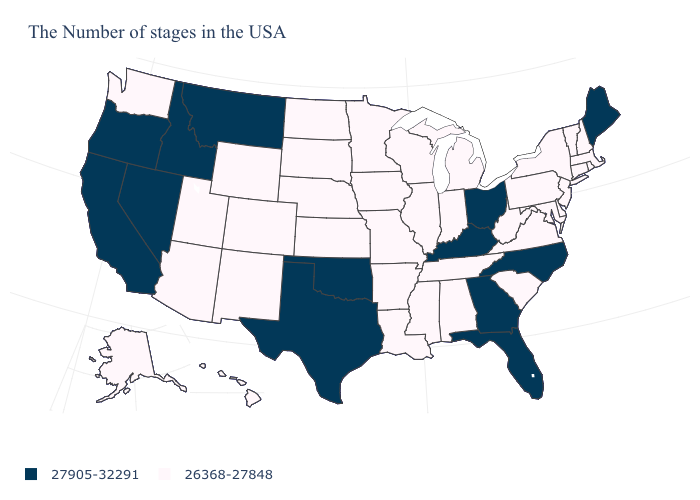What is the value of Alaska?
Quick response, please. 26368-27848. Does California have the same value as North Carolina?
Write a very short answer. Yes. Name the states that have a value in the range 26368-27848?
Answer briefly. Massachusetts, Rhode Island, New Hampshire, Vermont, Connecticut, New York, New Jersey, Delaware, Maryland, Pennsylvania, Virginia, South Carolina, West Virginia, Michigan, Indiana, Alabama, Tennessee, Wisconsin, Illinois, Mississippi, Louisiana, Missouri, Arkansas, Minnesota, Iowa, Kansas, Nebraska, South Dakota, North Dakota, Wyoming, Colorado, New Mexico, Utah, Arizona, Washington, Alaska, Hawaii. Among the states that border Oregon , does Idaho have the highest value?
Answer briefly. Yes. Name the states that have a value in the range 27905-32291?
Write a very short answer. Maine, North Carolina, Ohio, Florida, Georgia, Kentucky, Oklahoma, Texas, Montana, Idaho, Nevada, California, Oregon. What is the value of Louisiana?
Quick response, please. 26368-27848. Name the states that have a value in the range 27905-32291?
Be succinct. Maine, North Carolina, Ohio, Florida, Georgia, Kentucky, Oklahoma, Texas, Montana, Idaho, Nevada, California, Oregon. Which states have the lowest value in the West?
Be succinct. Wyoming, Colorado, New Mexico, Utah, Arizona, Washington, Alaska, Hawaii. What is the highest value in the USA?
Be succinct. 27905-32291. Among the states that border New Mexico , which have the highest value?
Concise answer only. Oklahoma, Texas. What is the value of Montana?
Be succinct. 27905-32291. What is the highest value in the South ?
Keep it brief. 27905-32291. What is the value of West Virginia?
Be succinct. 26368-27848. Among the states that border Kentucky , does Ohio have the highest value?
Write a very short answer. Yes. Does North Dakota have the same value as New Mexico?
Give a very brief answer. Yes. 